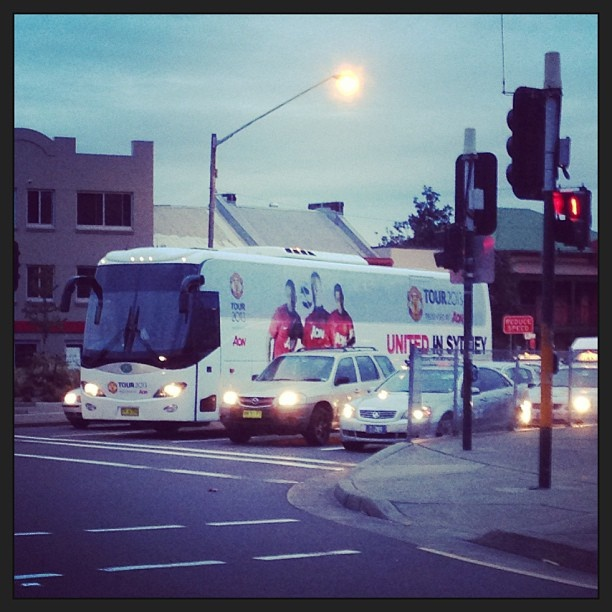Describe the objects in this image and their specific colors. I can see bus in black, darkgray, navy, and lightblue tones, car in black, darkgray, purple, gray, and ivory tones, car in black, gray, darkgray, and purple tones, traffic light in black, navy, darkgray, and lightblue tones, and traffic light in black, navy, gray, and purple tones in this image. 